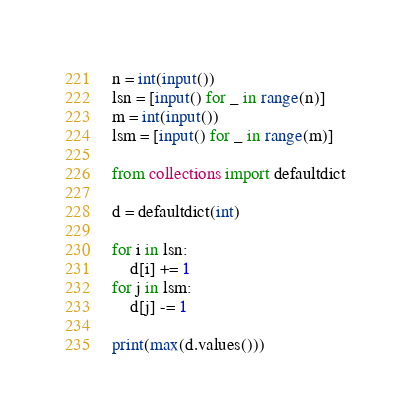Convert code to text. <code><loc_0><loc_0><loc_500><loc_500><_Python_>n = int(input())
lsn = [input() for _ in range(n)]
m = int(input())
lsm = [input() for _ in range(m)]
 
from collections import defaultdict
 
d = defaultdict(int)
 
for i in lsn:
    d[i] += 1
for j in lsm:
    d[j] -= 1
 
print(max(d.values()))</code> 